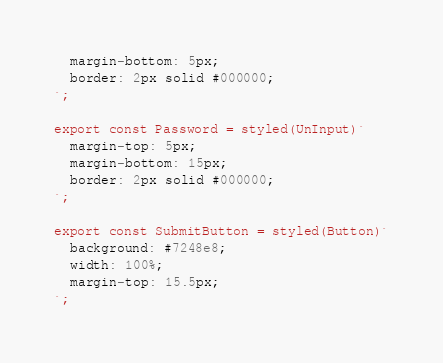<code> <loc_0><loc_0><loc_500><loc_500><_JavaScript_>  margin-bottom: 5px;
  border: 2px solid #000000;
`;

export const Password = styled(UnInput)`
  margin-top: 5px;
  margin-bottom: 15px;
  border: 2px solid #000000;
`;

export const SubmitButton = styled(Button)`
  background: #7248e8;
  width: 100%;
  margin-top: 15.5px;
`;
</code> 